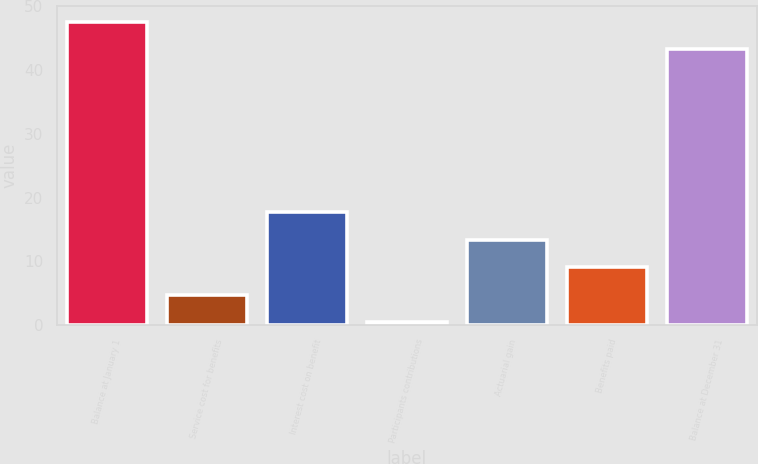<chart> <loc_0><loc_0><loc_500><loc_500><bar_chart><fcel>Balance at January 1<fcel>Service cost for benefits<fcel>Interest cost on benefit<fcel>Participants contributions<fcel>Actuarial gain<fcel>Benefits paid<fcel>Balance at December 31<nl><fcel>47.62<fcel>4.72<fcel>17.68<fcel>0.4<fcel>13.36<fcel>9.04<fcel>43.3<nl></chart> 